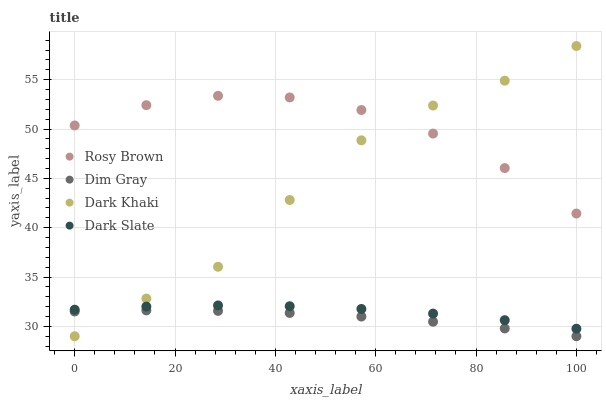Does Dim Gray have the minimum area under the curve?
Answer yes or no. Yes. Does Rosy Brown have the maximum area under the curve?
Answer yes or no. Yes. Does Dark Slate have the minimum area under the curve?
Answer yes or no. No. Does Dark Slate have the maximum area under the curve?
Answer yes or no. No. Is Dim Gray the smoothest?
Answer yes or no. Yes. Is Dark Khaki the roughest?
Answer yes or no. Yes. Is Dark Slate the smoothest?
Answer yes or no. No. Is Dark Slate the roughest?
Answer yes or no. No. Does Dark Khaki have the lowest value?
Answer yes or no. Yes. Does Dark Slate have the lowest value?
Answer yes or no. No. Does Dark Khaki have the highest value?
Answer yes or no. Yes. Does Dark Slate have the highest value?
Answer yes or no. No. Is Dark Slate less than Rosy Brown?
Answer yes or no. Yes. Is Rosy Brown greater than Dark Slate?
Answer yes or no. Yes. Does Dark Slate intersect Dark Khaki?
Answer yes or no. Yes. Is Dark Slate less than Dark Khaki?
Answer yes or no. No. Is Dark Slate greater than Dark Khaki?
Answer yes or no. No. Does Dark Slate intersect Rosy Brown?
Answer yes or no. No. 